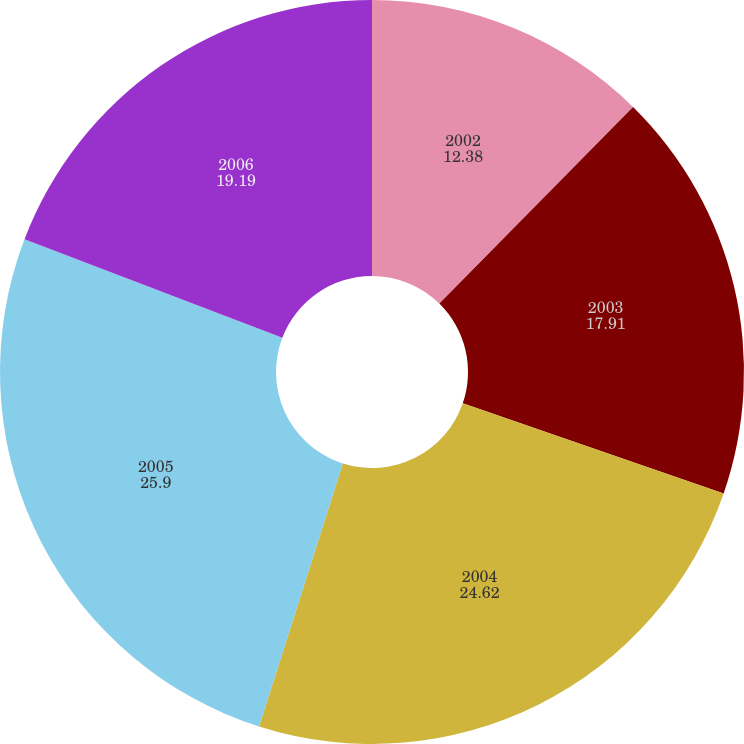Convert chart to OTSL. <chart><loc_0><loc_0><loc_500><loc_500><pie_chart><fcel>2002<fcel>2003<fcel>2004<fcel>2005<fcel>2006<nl><fcel>12.38%<fcel>17.91%<fcel>24.62%<fcel>25.9%<fcel>19.19%<nl></chart> 